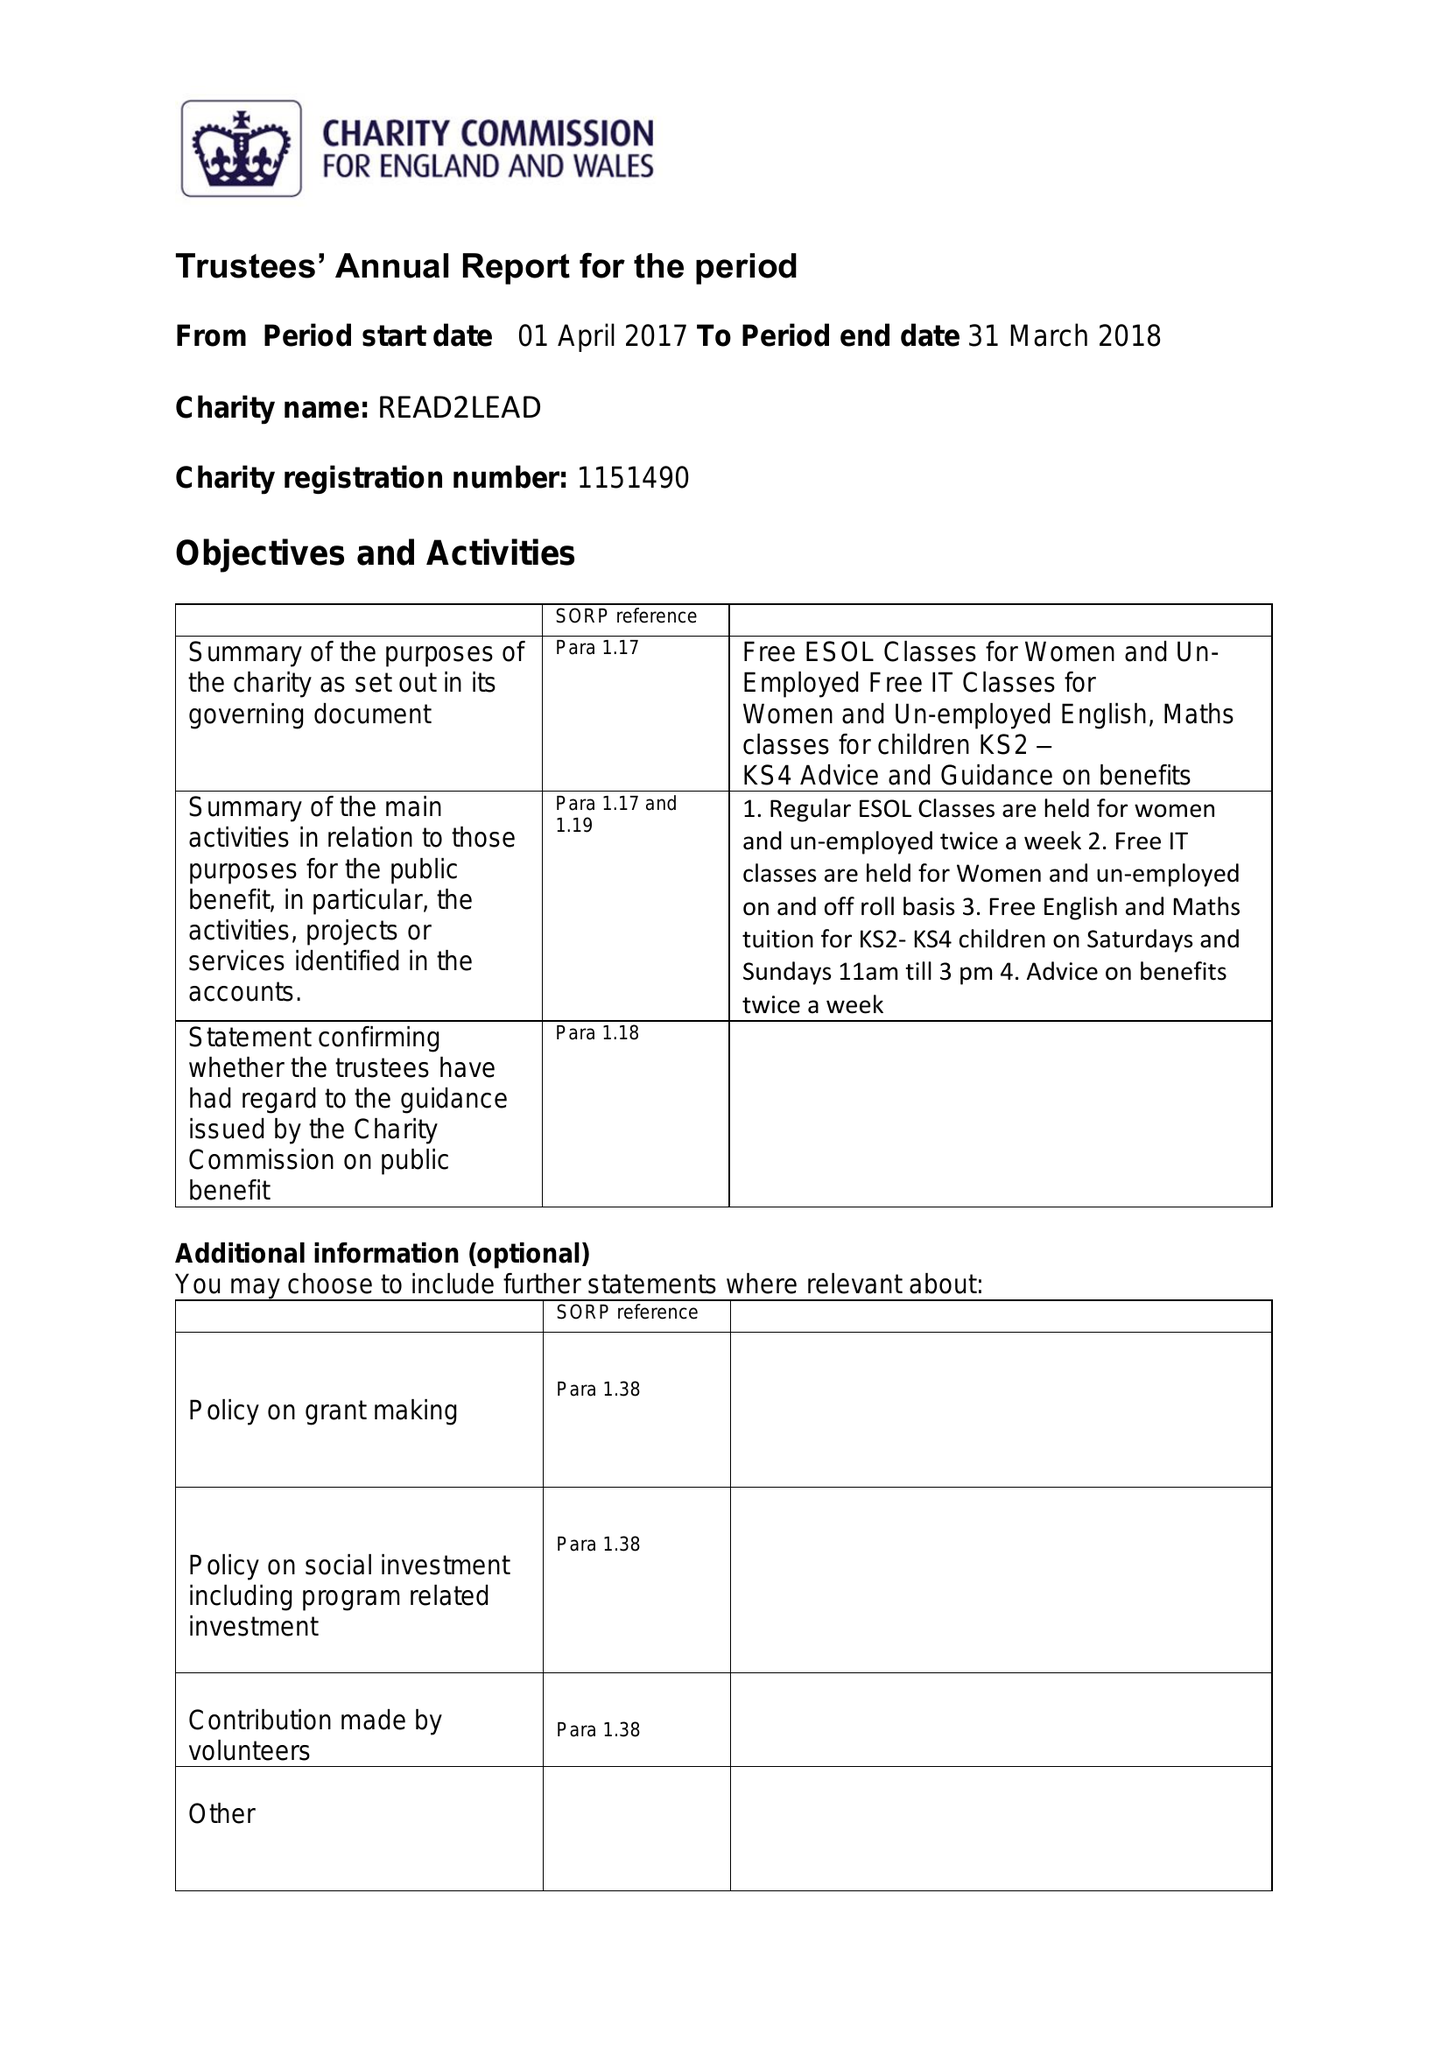What is the value for the address__postcode?
Answer the question using a single word or phrase. B8 1RS 